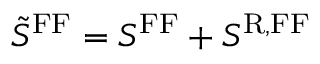Convert formula to latex. <formula><loc_0><loc_0><loc_500><loc_500>\tilde { S } ^ { F F } = S ^ { F F } + S ^ { R , F F }</formula> 